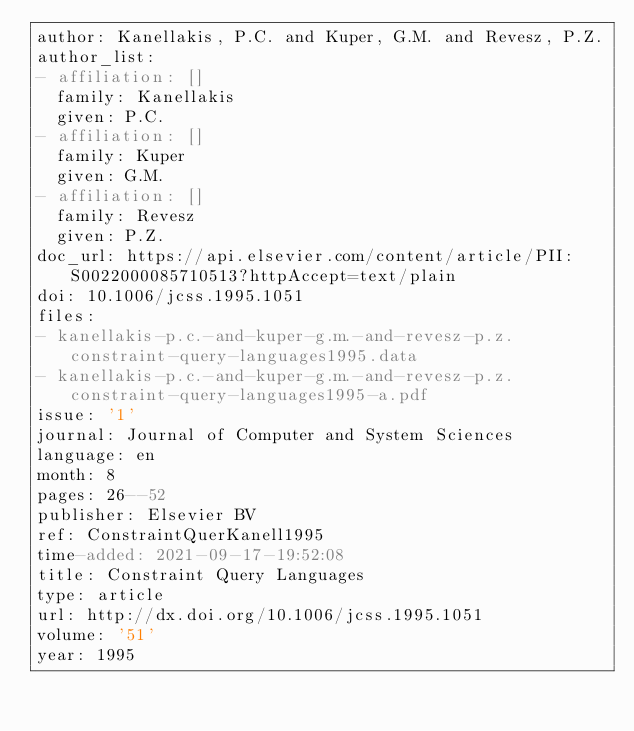<code> <loc_0><loc_0><loc_500><loc_500><_YAML_>author: Kanellakis, P.C. and Kuper, G.M. and Revesz, P.Z.
author_list:
- affiliation: []
  family: Kanellakis
  given: P.C.
- affiliation: []
  family: Kuper
  given: G.M.
- affiliation: []
  family: Revesz
  given: P.Z.
doc_url: https://api.elsevier.com/content/article/PII:S0022000085710513?httpAccept=text/plain
doi: 10.1006/jcss.1995.1051
files:
- kanellakis-p.c.-and-kuper-g.m.-and-revesz-p.z.constraint-query-languages1995.data
- kanellakis-p.c.-and-kuper-g.m.-and-revesz-p.z.constraint-query-languages1995-a.pdf
issue: '1'
journal: Journal of Computer and System Sciences
language: en
month: 8
pages: 26--52
publisher: Elsevier BV
ref: ConstraintQuerKanell1995
time-added: 2021-09-17-19:52:08
title: Constraint Query Languages
type: article
url: http://dx.doi.org/10.1006/jcss.1995.1051
volume: '51'
year: 1995
</code> 